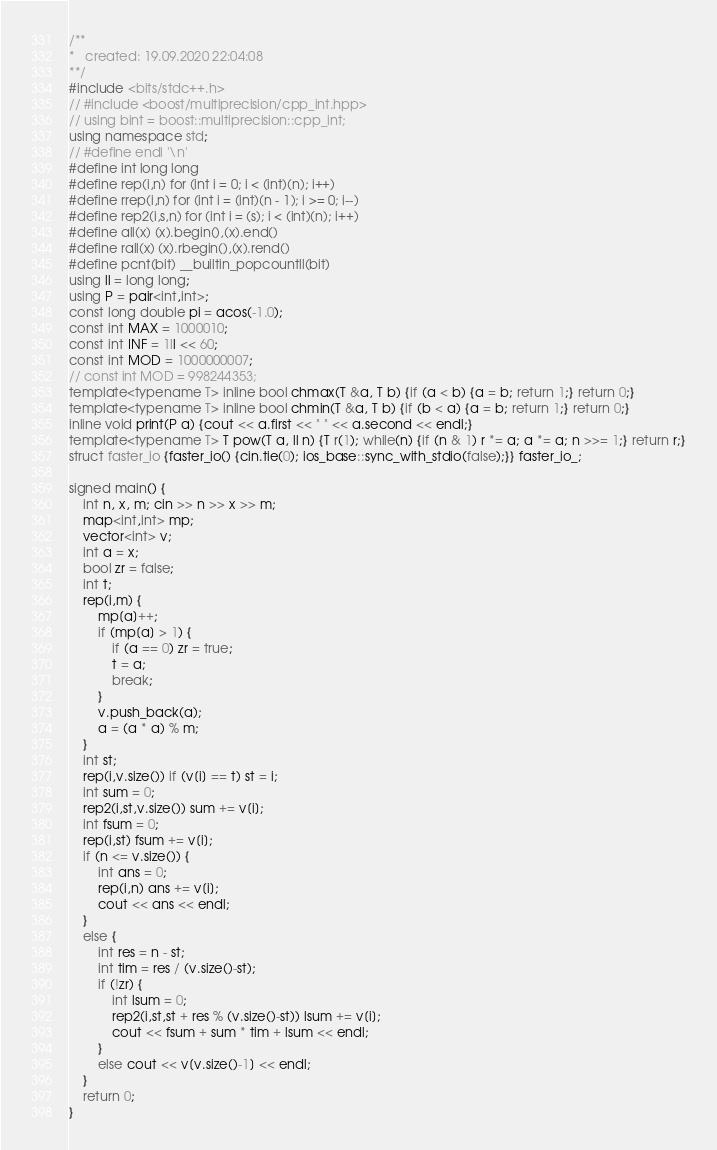Convert code to text. <code><loc_0><loc_0><loc_500><loc_500><_C++_>/**
*	created: 19.09.2020 22:04:08
**/
#include <bits/stdc++.h>
// #include <boost/multiprecision/cpp_int.hpp>
// using bint = boost::multiprecision::cpp_int;
using namespace std;
// #define endl '\n'
#define int long long
#define rep(i,n) for (int i = 0; i < (int)(n); i++)
#define rrep(i,n) for (int i = (int)(n - 1); i >= 0; i--)
#define rep2(i,s,n) for (int i = (s); i < (int)(n); i++)
#define all(x) (x).begin(),(x).end()
#define rall(x) (x).rbegin(),(x).rend()
#define pcnt(bit) __builtin_popcountll(bit)
using ll = long long;
using P = pair<int,int>;
const long double pi = acos(-1.0);
const int MAX = 1000010;
const int INF = 1ll << 60;
const int MOD = 1000000007;
// const int MOD = 998244353;
template<typename T> inline bool chmax(T &a, T b) {if (a < b) {a = b; return 1;} return 0;}
template<typename T> inline bool chmin(T &a, T b) {if (b < a) {a = b; return 1;} return 0;}
inline void print(P a) {cout << a.first << " " << a.second << endl;}
template<typename T> T pow(T a, ll n) {T r(1); while(n) {if (n & 1) r *= a; a *= a; n >>= 1;} return r;}
struct faster_io {faster_io() {cin.tie(0); ios_base::sync_with_stdio(false);}} faster_io_;

signed main() {
    int n, x, m; cin >> n >> x >> m;
    map<int,int> mp;
    vector<int> v;
    int a = x;
    bool zr = false;
    int t;
    rep(i,m) {
        mp[a]++;
        if (mp[a] > 1) {
            if (a == 0) zr = true;
            t = a;
            break;
        }
        v.push_back(a);
        a = (a * a) % m;
    }
    int st;
    rep(i,v.size()) if (v[i] == t) st = i;
    int sum = 0;
    rep2(i,st,v.size()) sum += v[i];
    int fsum = 0;
    rep(i,st) fsum += v[i];
    if (n <= v.size()) {
        int ans = 0;
        rep(i,n) ans += v[i];
        cout << ans << endl;
    }
    else {
        int res = n - st;
        int tim = res / (v.size()-st);
        if (!zr) {
            int lsum = 0;
            rep2(i,st,st + res % (v.size()-st)) lsum += v[i];
            cout << fsum + sum * tim + lsum << endl;
        }
        else cout << v[v.size()-1] << endl;
    }
    return 0;
}</code> 